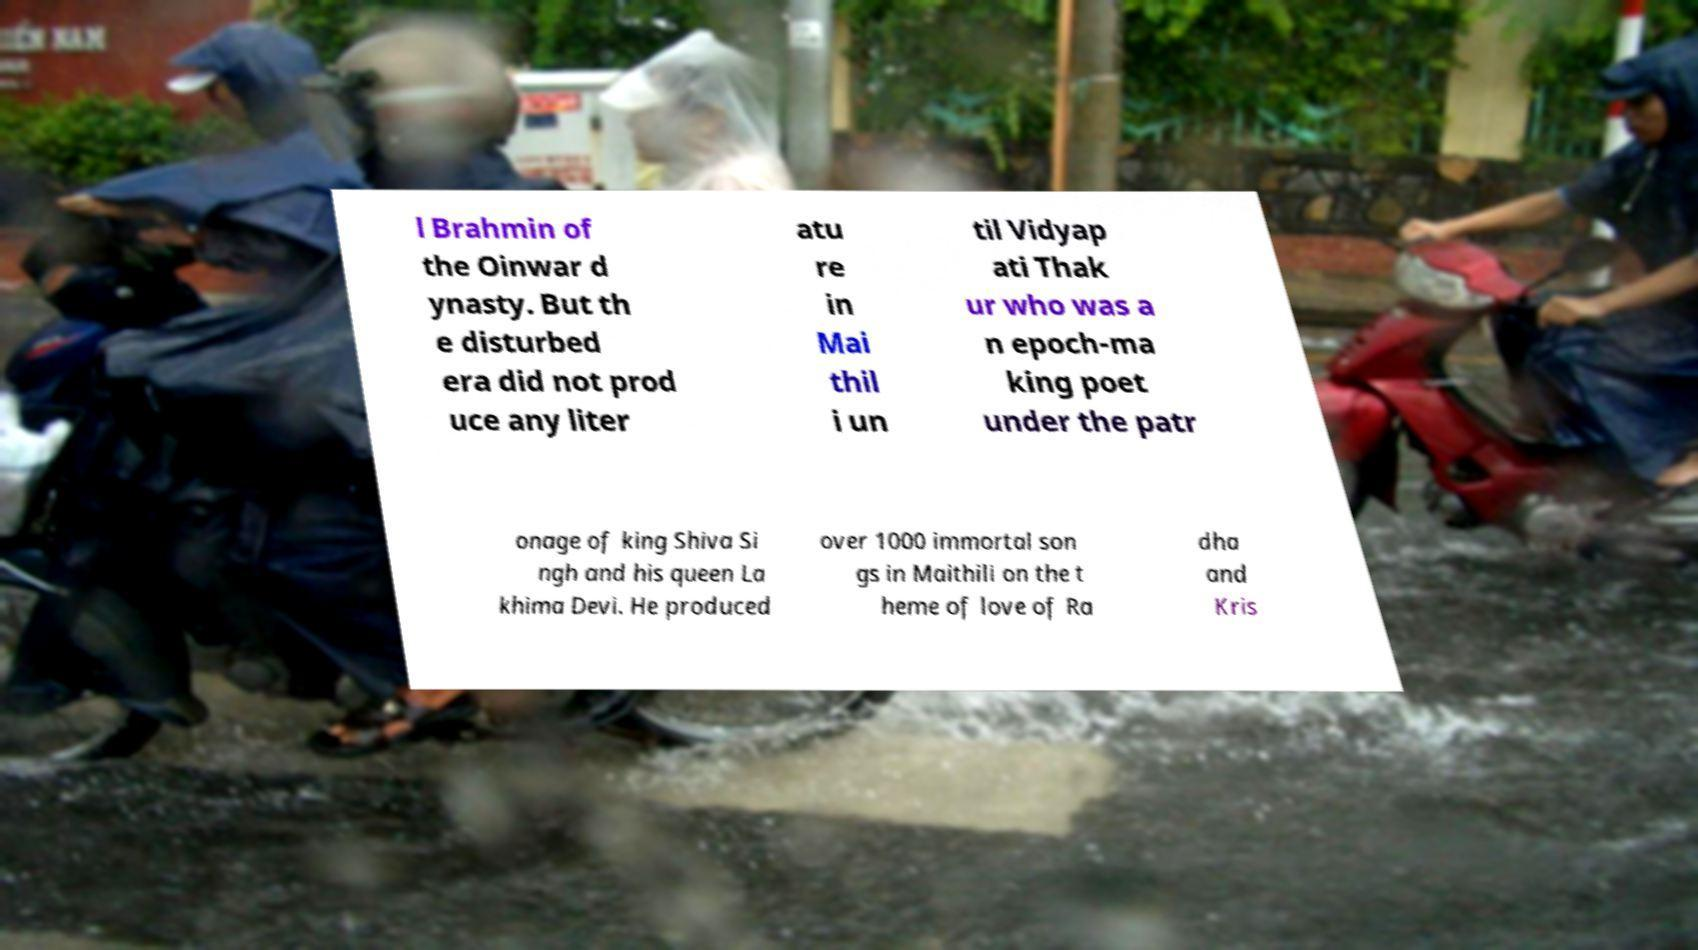Could you extract and type out the text from this image? l Brahmin of the Oinwar d ynasty. But th e disturbed era did not prod uce any liter atu re in Mai thil i un til Vidyap ati Thak ur who was a n epoch-ma king poet under the patr onage of king Shiva Si ngh and his queen La khima Devi. He produced over 1000 immortal son gs in Maithili on the t heme of love of Ra dha and Kris 